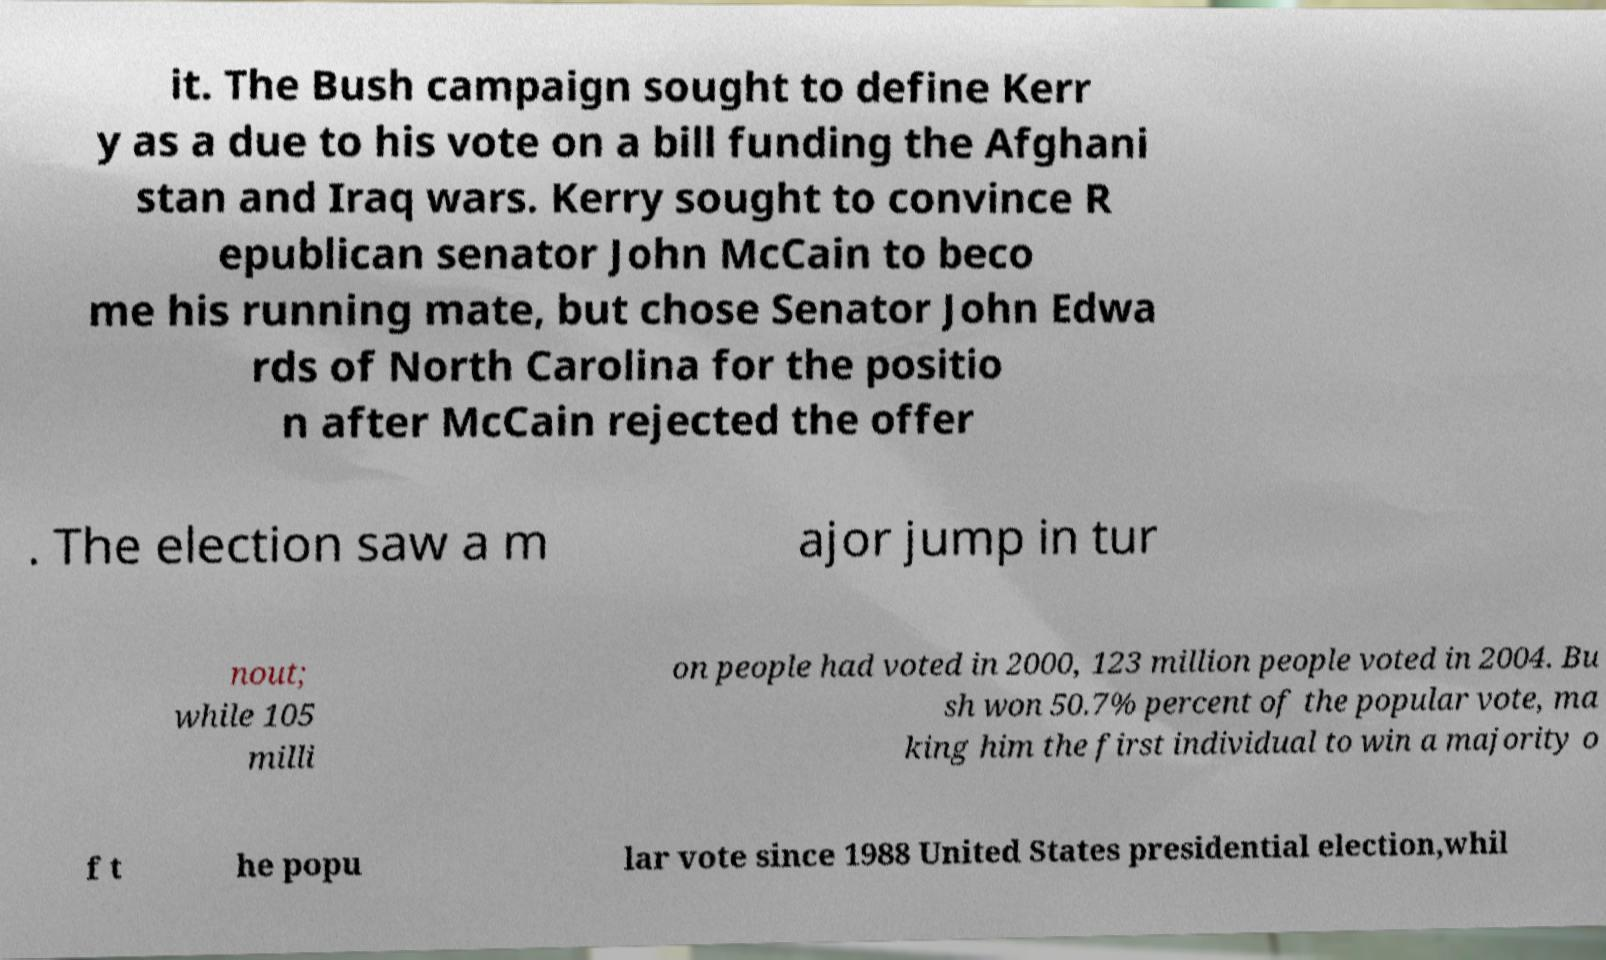Could you assist in decoding the text presented in this image and type it out clearly? it. The Bush campaign sought to define Kerr y as a due to his vote on a bill funding the Afghani stan and Iraq wars. Kerry sought to convince R epublican senator John McCain to beco me his running mate, but chose Senator John Edwa rds of North Carolina for the positio n after McCain rejected the offer . The election saw a m ajor jump in tur nout; while 105 milli on people had voted in 2000, 123 million people voted in 2004. Bu sh won 50.7% percent of the popular vote, ma king him the first individual to win a majority o f t he popu lar vote since 1988 United States presidential election,whil 